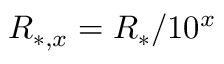Convert formula to latex. <formula><loc_0><loc_0><loc_500><loc_500>R _ { * , x } = R _ { * } / 1 0 ^ { x }</formula> 